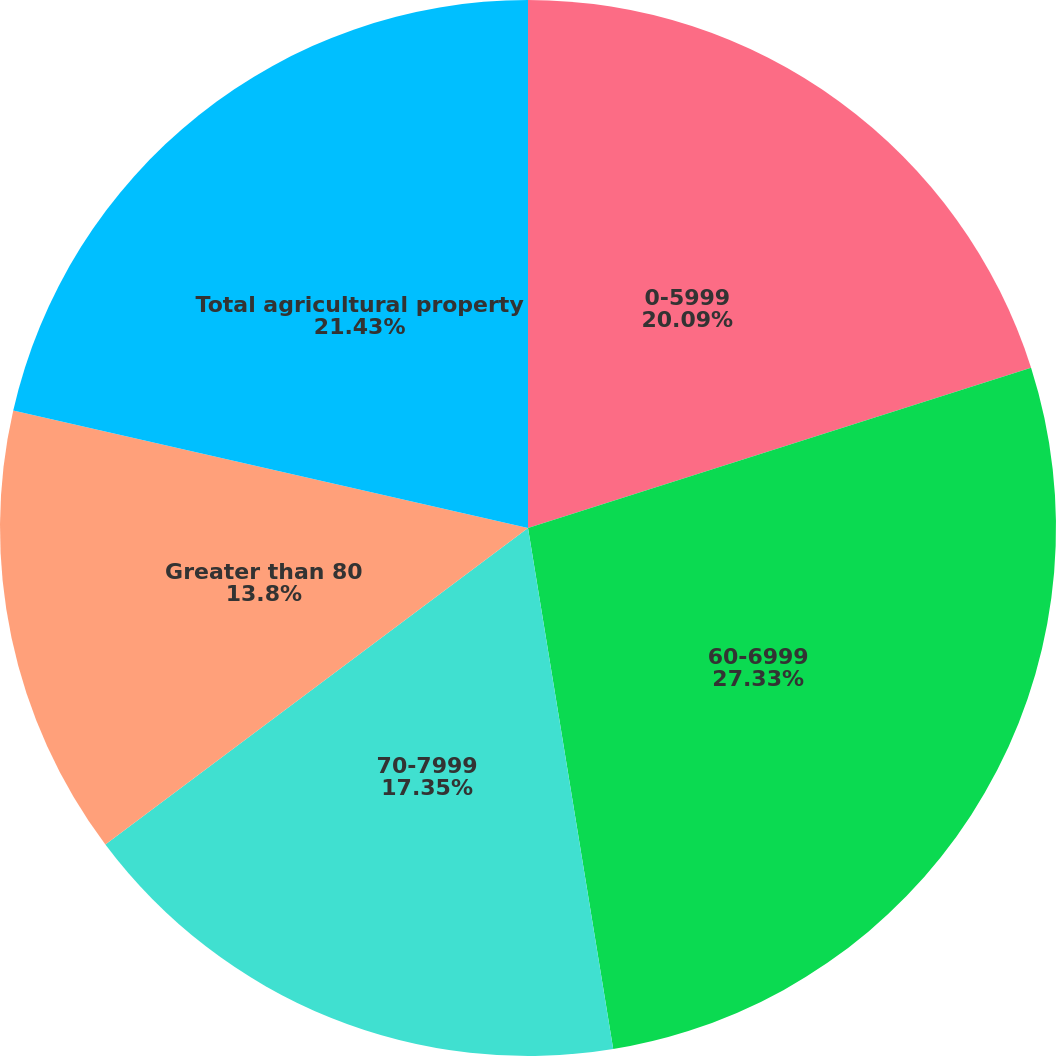Convert chart to OTSL. <chart><loc_0><loc_0><loc_500><loc_500><pie_chart><fcel>0-5999<fcel>60-6999<fcel>70-7999<fcel>Greater than 80<fcel>Total agricultural property<nl><fcel>20.09%<fcel>27.33%<fcel>17.35%<fcel>13.8%<fcel>21.43%<nl></chart> 